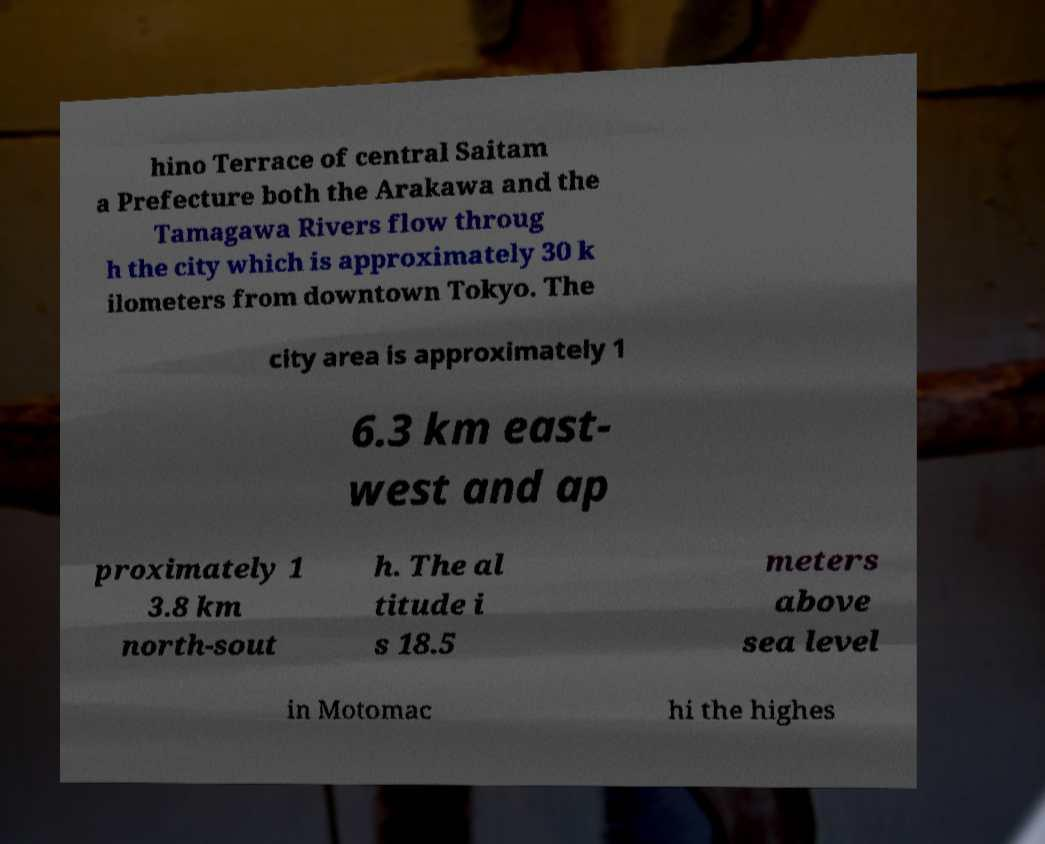I need the written content from this picture converted into text. Can you do that? hino Terrace of central Saitam a Prefecture both the Arakawa and the Tamagawa Rivers flow throug h the city which is approximately 30 k ilometers from downtown Tokyo. The city area is approximately 1 6.3 km east- west and ap proximately 1 3.8 km north-sout h. The al titude i s 18.5 meters above sea level in Motomac hi the highes 